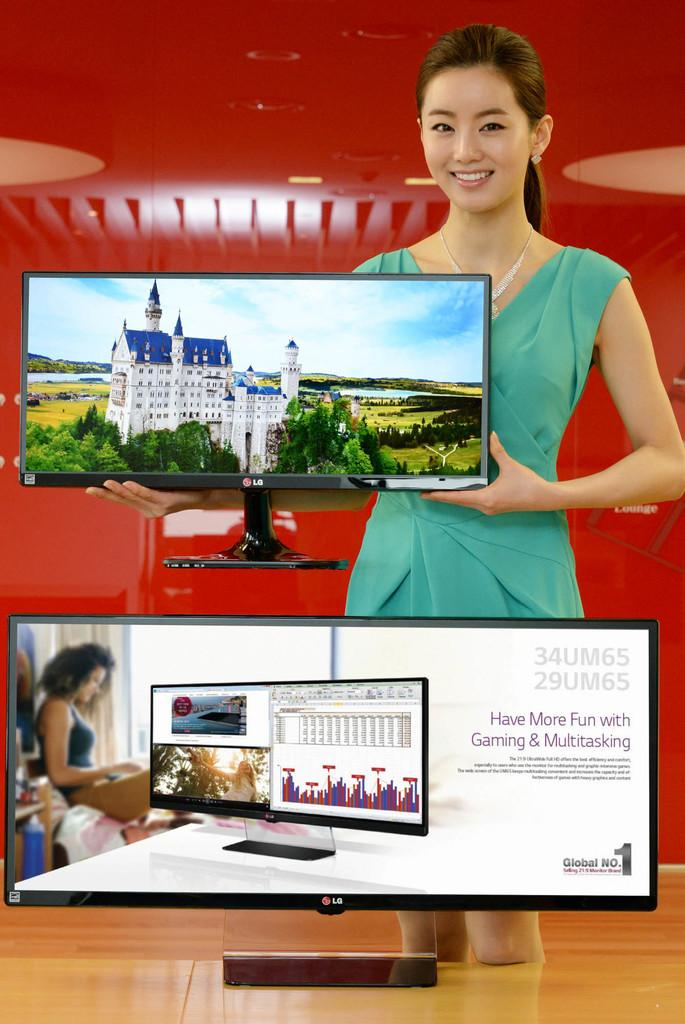<image>
Relay a brief, clear account of the picture shown. A woman holds up a LG monitor showing a pretty castle. 